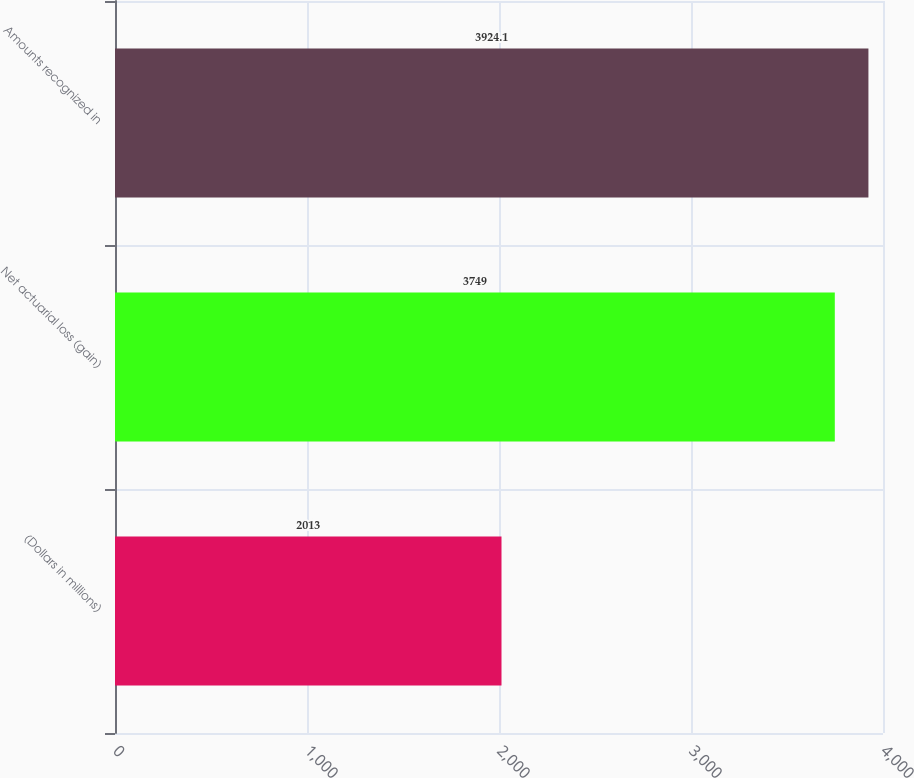Convert chart to OTSL. <chart><loc_0><loc_0><loc_500><loc_500><bar_chart><fcel>(Dollars in millions)<fcel>Net actuarial loss (gain)<fcel>Amounts recognized in<nl><fcel>2013<fcel>3749<fcel>3924.1<nl></chart> 